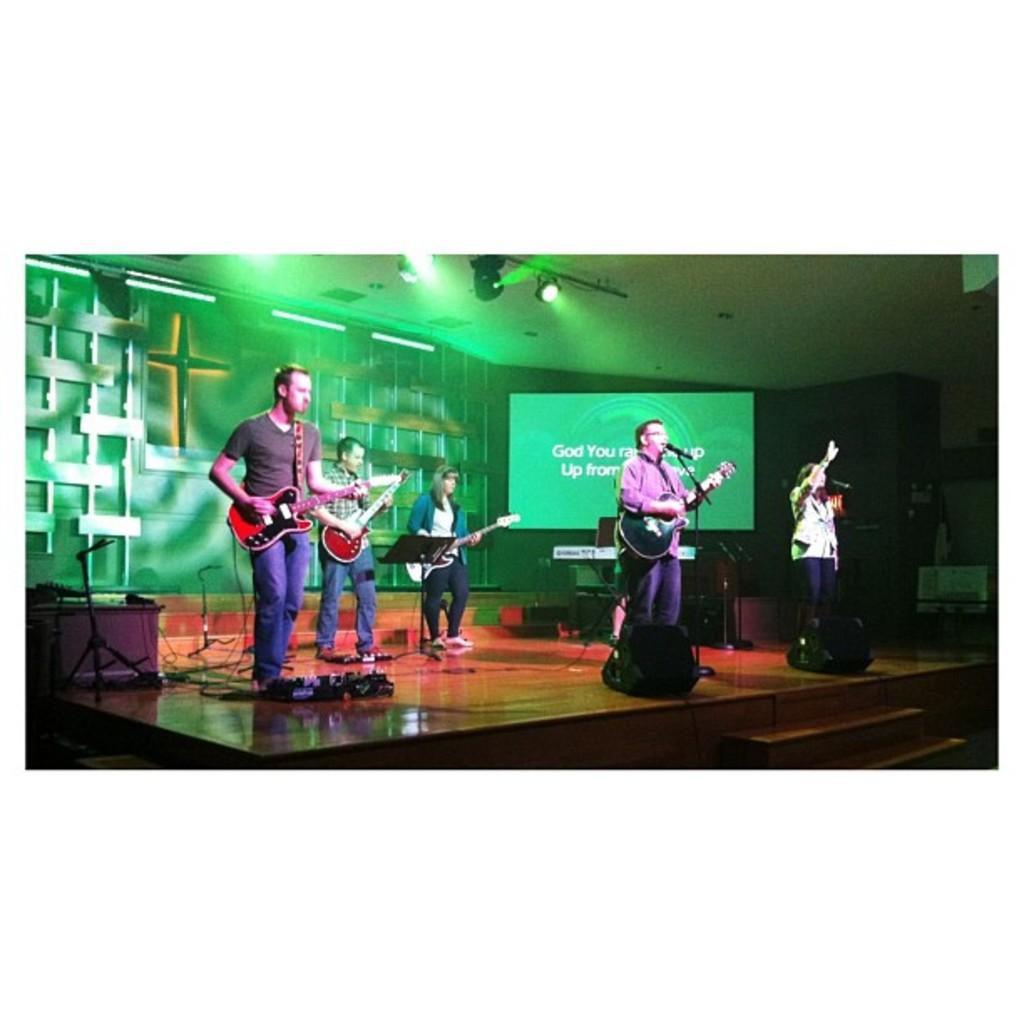What are the persons on stage doing? The persons on stage are playing musical instruments. What can be seen in the background behind the stage? There is a wall and a screen in the background. Is there any source of illumination visible in the image? Yes, there is a light at the top of the image. What type of jam is being spread on the screen in the background? There is no jam present in the image, and the screen is not being used for spreading jam. 